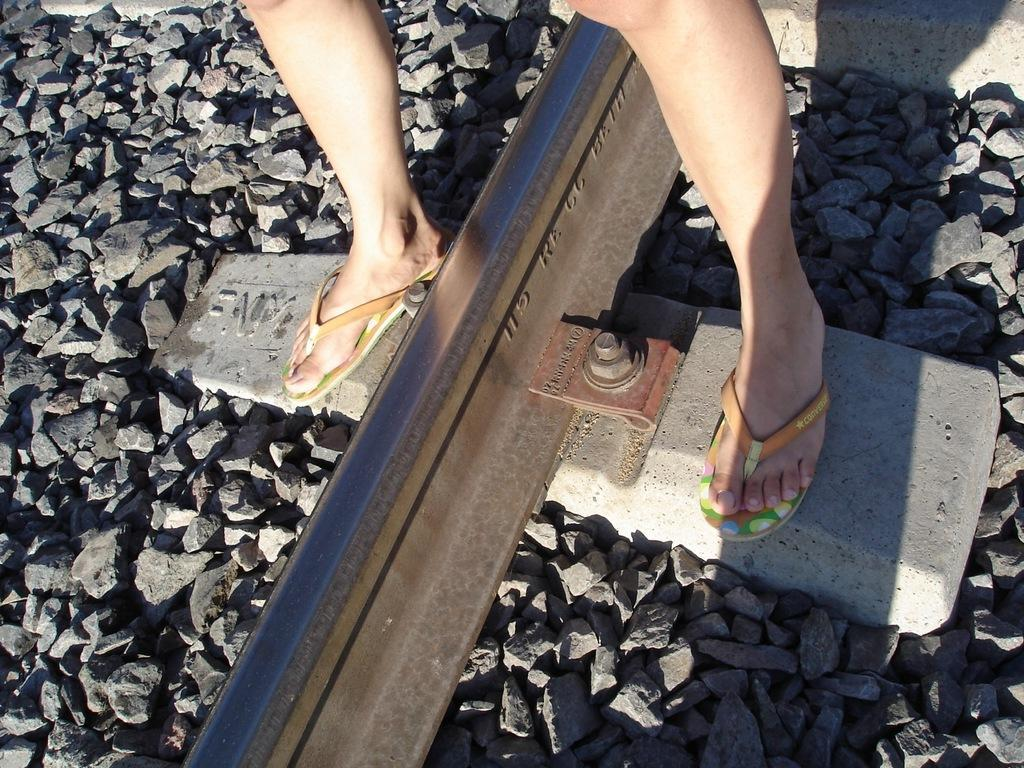What is the main subject of the image? There is a person standing in the image. What can be seen in the background of the image? There is a track with stones at the bottom of the image. What small objects are visible in the image? A nut and a bolt are visible in the image. How many flags can be seen flying in the image? There are no flags visible in the image. What is the distance between the person and the nut and bolt in the image? The provided facts do not give information about the distance between the person and the nut and bolt. 